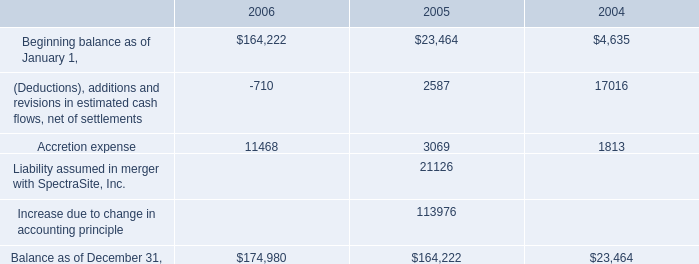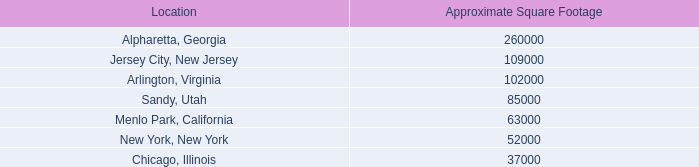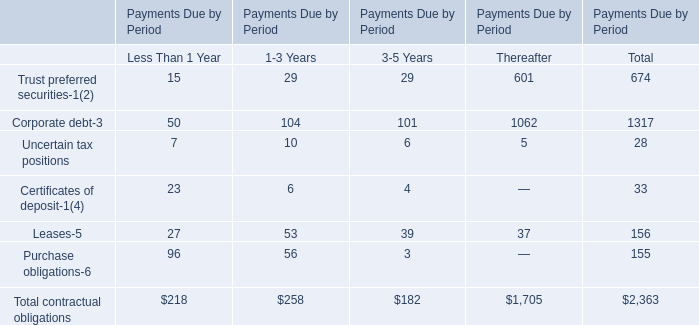What is the row number of the kind of contractual obligations which is the highest in terms of Payments Due for Less Than 1 Year? 
Answer: 7. 